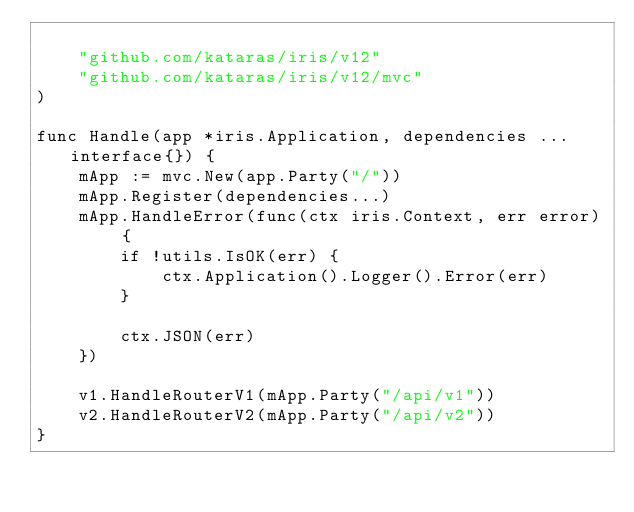<code> <loc_0><loc_0><loc_500><loc_500><_Go_>
	"github.com/kataras/iris/v12"
	"github.com/kataras/iris/v12/mvc"
)

func Handle(app *iris.Application, dependencies ...interface{}) {
	mApp := mvc.New(app.Party("/"))
	mApp.Register(dependencies...)
	mApp.HandleError(func(ctx iris.Context, err error) {
		if !utils.IsOK(err) {
			ctx.Application().Logger().Error(err)
		}

		ctx.JSON(err)
	})

	v1.HandleRouterV1(mApp.Party("/api/v1"))
	v2.HandleRouterV2(mApp.Party("/api/v2"))
}
</code> 